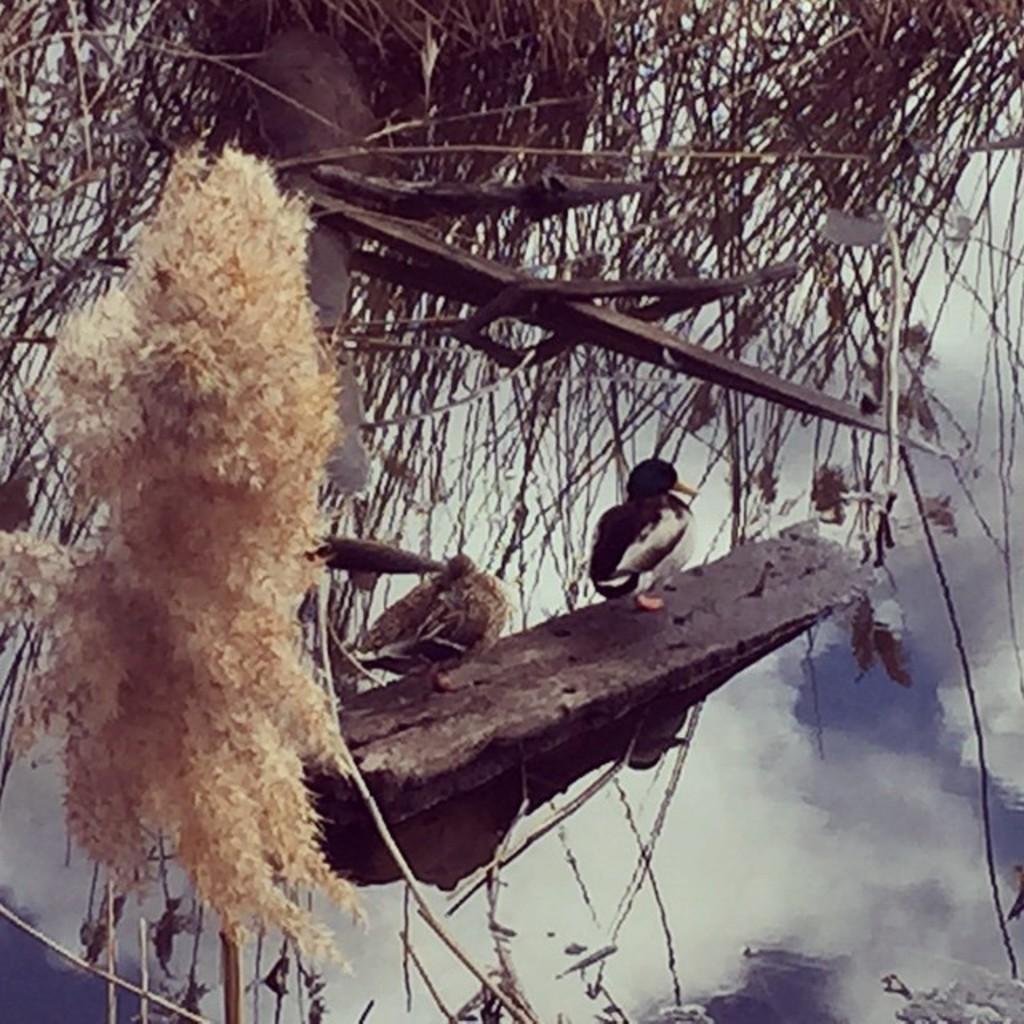How would you summarize this image in a sentence or two? In this image there are two birds standing on the wooden stick. At the top there is grass. On the left side there is a nest. At the bottom there are clouds. 